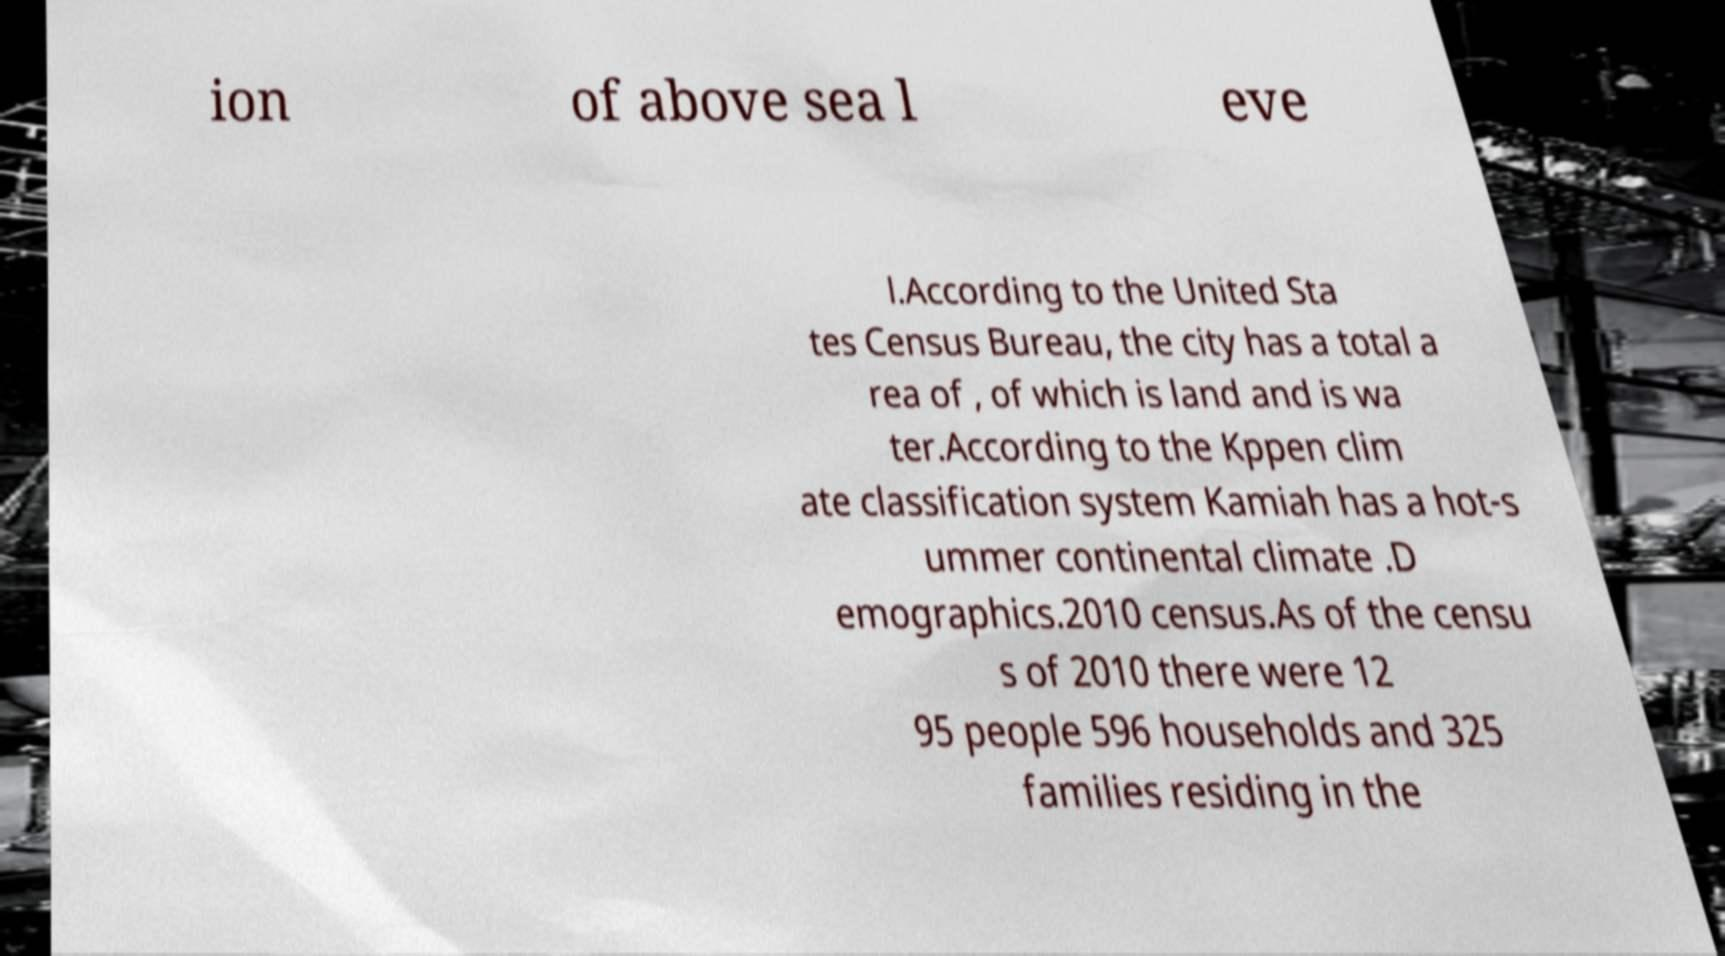I need the written content from this picture converted into text. Can you do that? ion of above sea l eve l.According to the United Sta tes Census Bureau, the city has a total a rea of , of which is land and is wa ter.According to the Kppen clim ate classification system Kamiah has a hot-s ummer continental climate .D emographics.2010 census.As of the censu s of 2010 there were 12 95 people 596 households and 325 families residing in the 